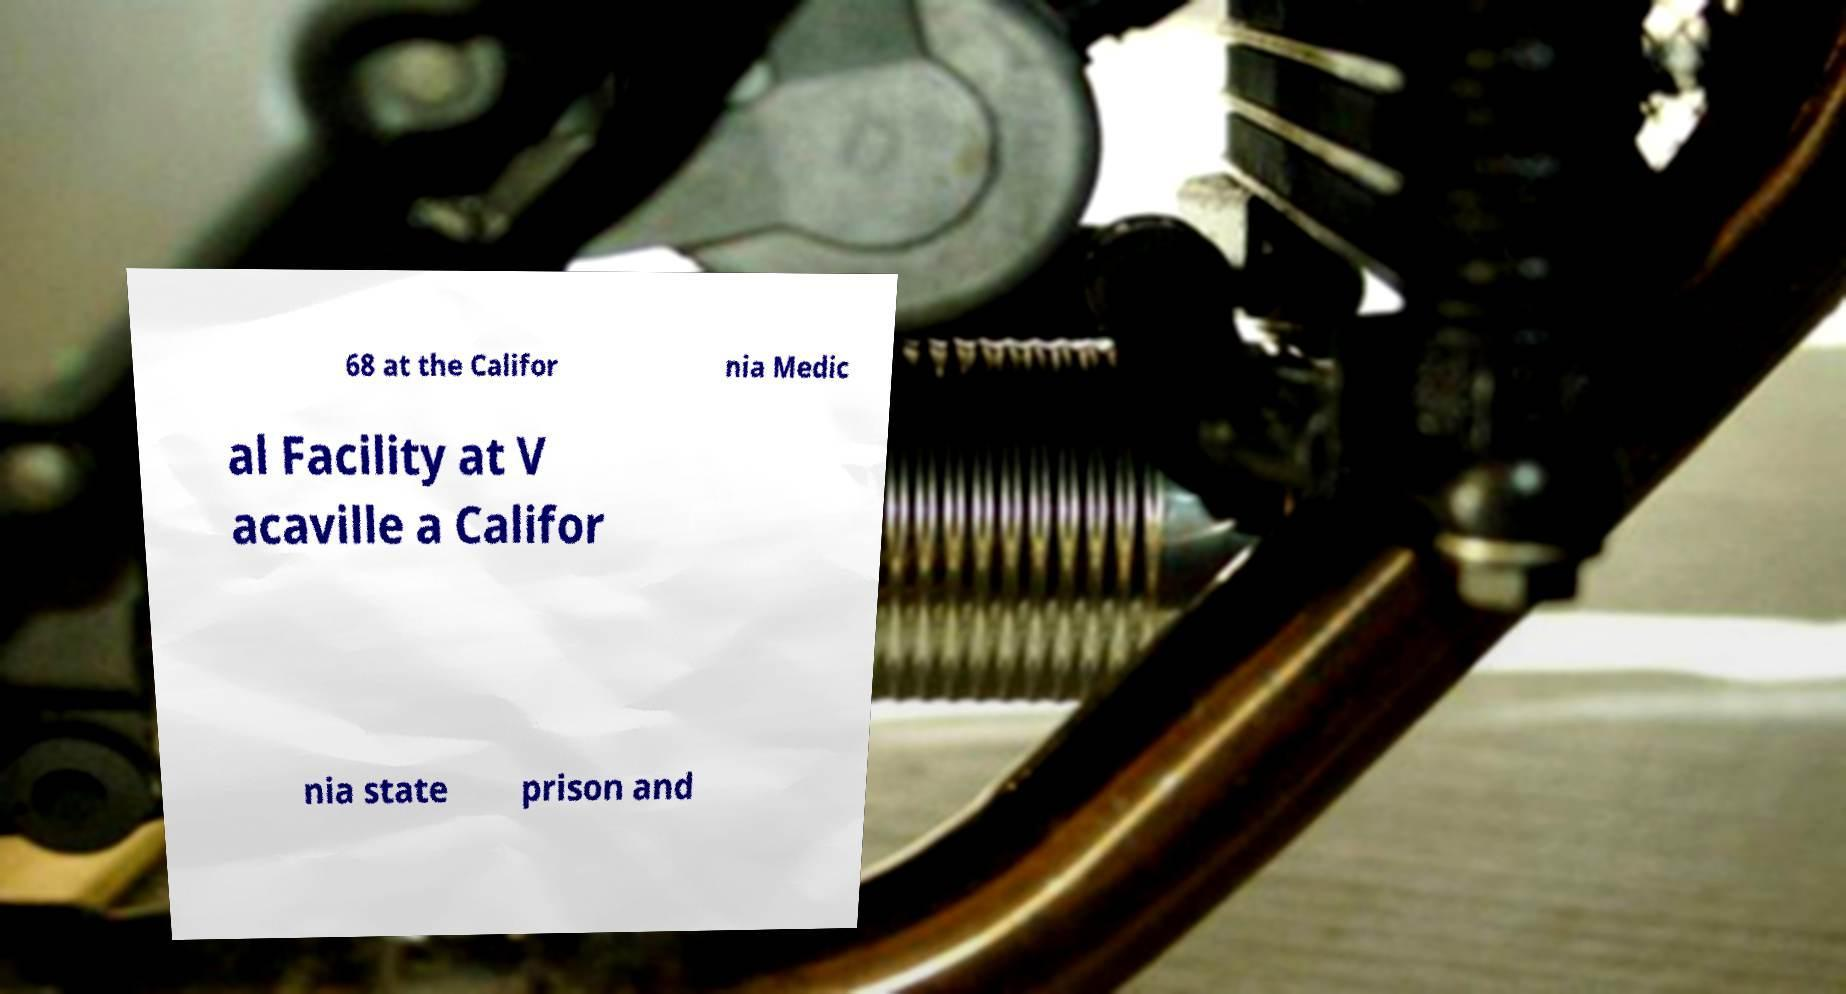For documentation purposes, I need the text within this image transcribed. Could you provide that? 68 at the Califor nia Medic al Facility at V acaville a Califor nia state prison and 